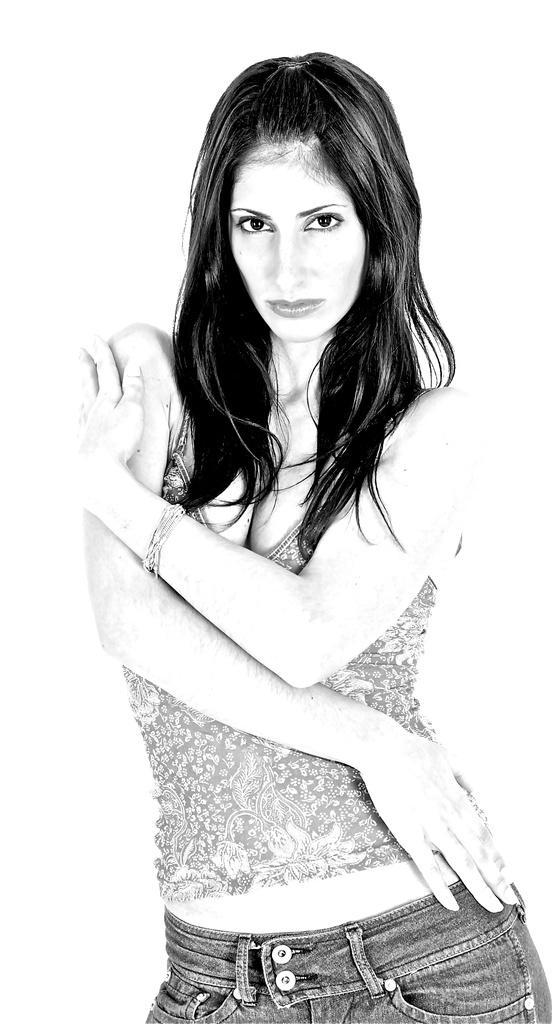In one or two sentences, can you explain what this image depicts? In the image a woman is standing and watching. 